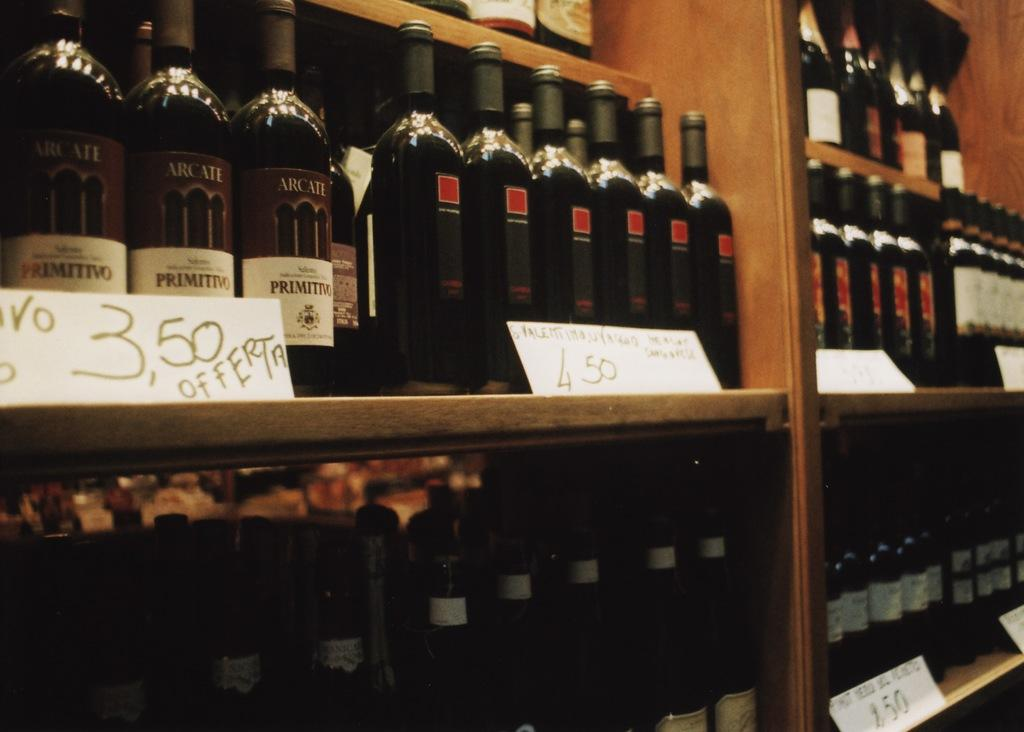<image>
Create a compact narrative representing the image presented. Several bottles of Primitivo wine displayed for sale with other various wines. 